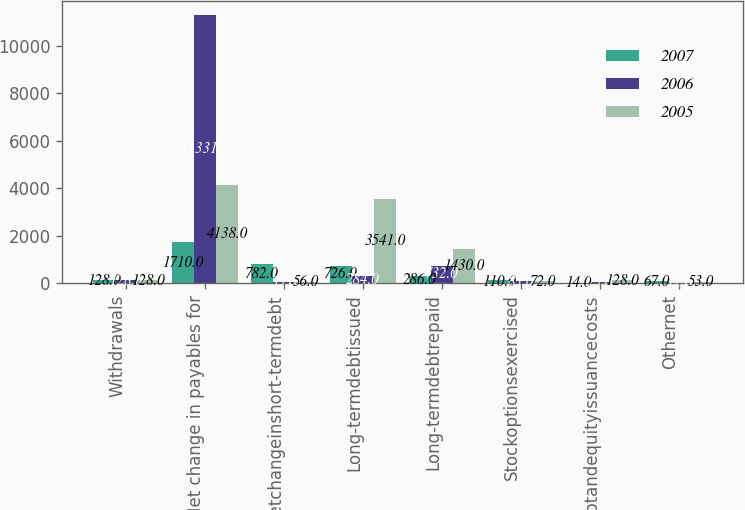Convert chart. <chart><loc_0><loc_0><loc_500><loc_500><stacked_bar_chart><ecel><fcel>Withdrawals<fcel>Net change in payables for<fcel>Netchangeinshort-termdebt<fcel>Long-termdebtissued<fcel>Long-termdebtrepaid<fcel>Stockoptionsexercised<fcel>Debtandequityissuancecosts<fcel>Othernet<nl><fcel>2007<fcel>128<fcel>1710<fcel>782<fcel>726<fcel>286<fcel>110<fcel>14<fcel>67<nl><fcel>2006<fcel>128<fcel>11331<fcel>35<fcel>284<fcel>732<fcel>83<fcel>25<fcel>12<nl><fcel>2005<fcel>128<fcel>4138<fcel>56<fcel>3541<fcel>1430<fcel>72<fcel>128<fcel>53<nl></chart> 